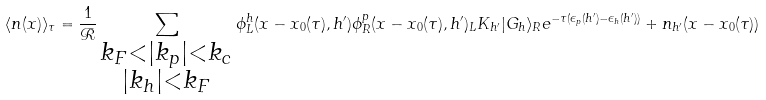Convert formula to latex. <formula><loc_0><loc_0><loc_500><loc_500>\langle n ( x ) \rangle _ { \tau } = \frac { 1 } { \mathcal { R } } \sum _ { \substack { k _ { F } < | k _ { p } | < k _ { c } \\ | k _ { h } | < k _ { F } } } \phi ^ { h } _ { L } ( x - x _ { 0 } ( \tau ) , h ^ { \prime } ) \phi ^ { p } _ { R } ( x - x _ { 0 } ( \tau ) , h ^ { \prime } ) _ { L } K _ { h ^ { \prime } } | G _ { h } \rangle _ { R } e ^ { - \tau ( \epsilon _ { p } ( h ^ { \prime } ) - \epsilon _ { h } ( h ^ { \prime } ) ) } + n _ { h ^ { \prime } } ( x - x _ { 0 } ( \tau ) )</formula> 